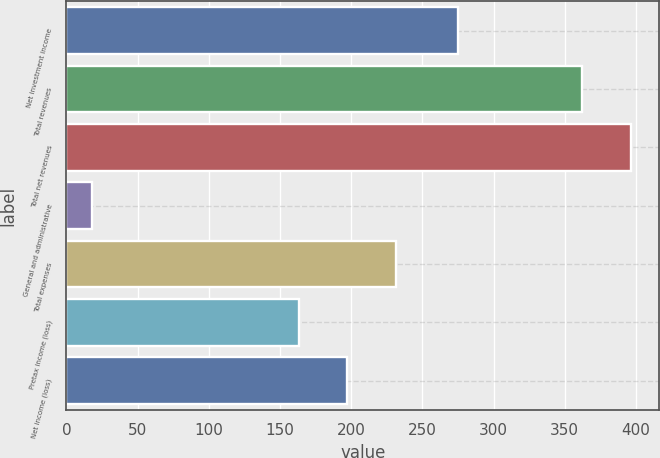Convert chart. <chart><loc_0><loc_0><loc_500><loc_500><bar_chart><fcel>Net investment income<fcel>Total revenues<fcel>Total net revenues<fcel>General and administrative<fcel>Total expenses<fcel>Pretax income (loss)<fcel>Net income (loss)<nl><fcel>275<fcel>362<fcel>396.4<fcel>18<fcel>231.8<fcel>163<fcel>197.4<nl></chart> 